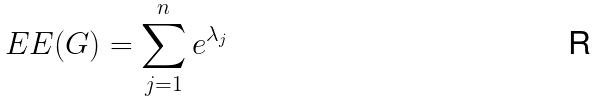<formula> <loc_0><loc_0><loc_500><loc_500>E E ( G ) = \sum _ { j = 1 } ^ { n } e ^ { \lambda _ { j } }</formula> 